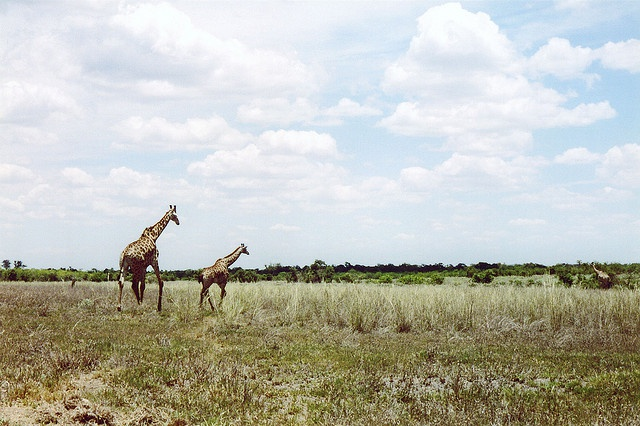Describe the objects in this image and their specific colors. I can see giraffe in lightgray, black, maroon, olive, and tan tones and giraffe in lightgray, black, maroon, tan, and olive tones in this image. 